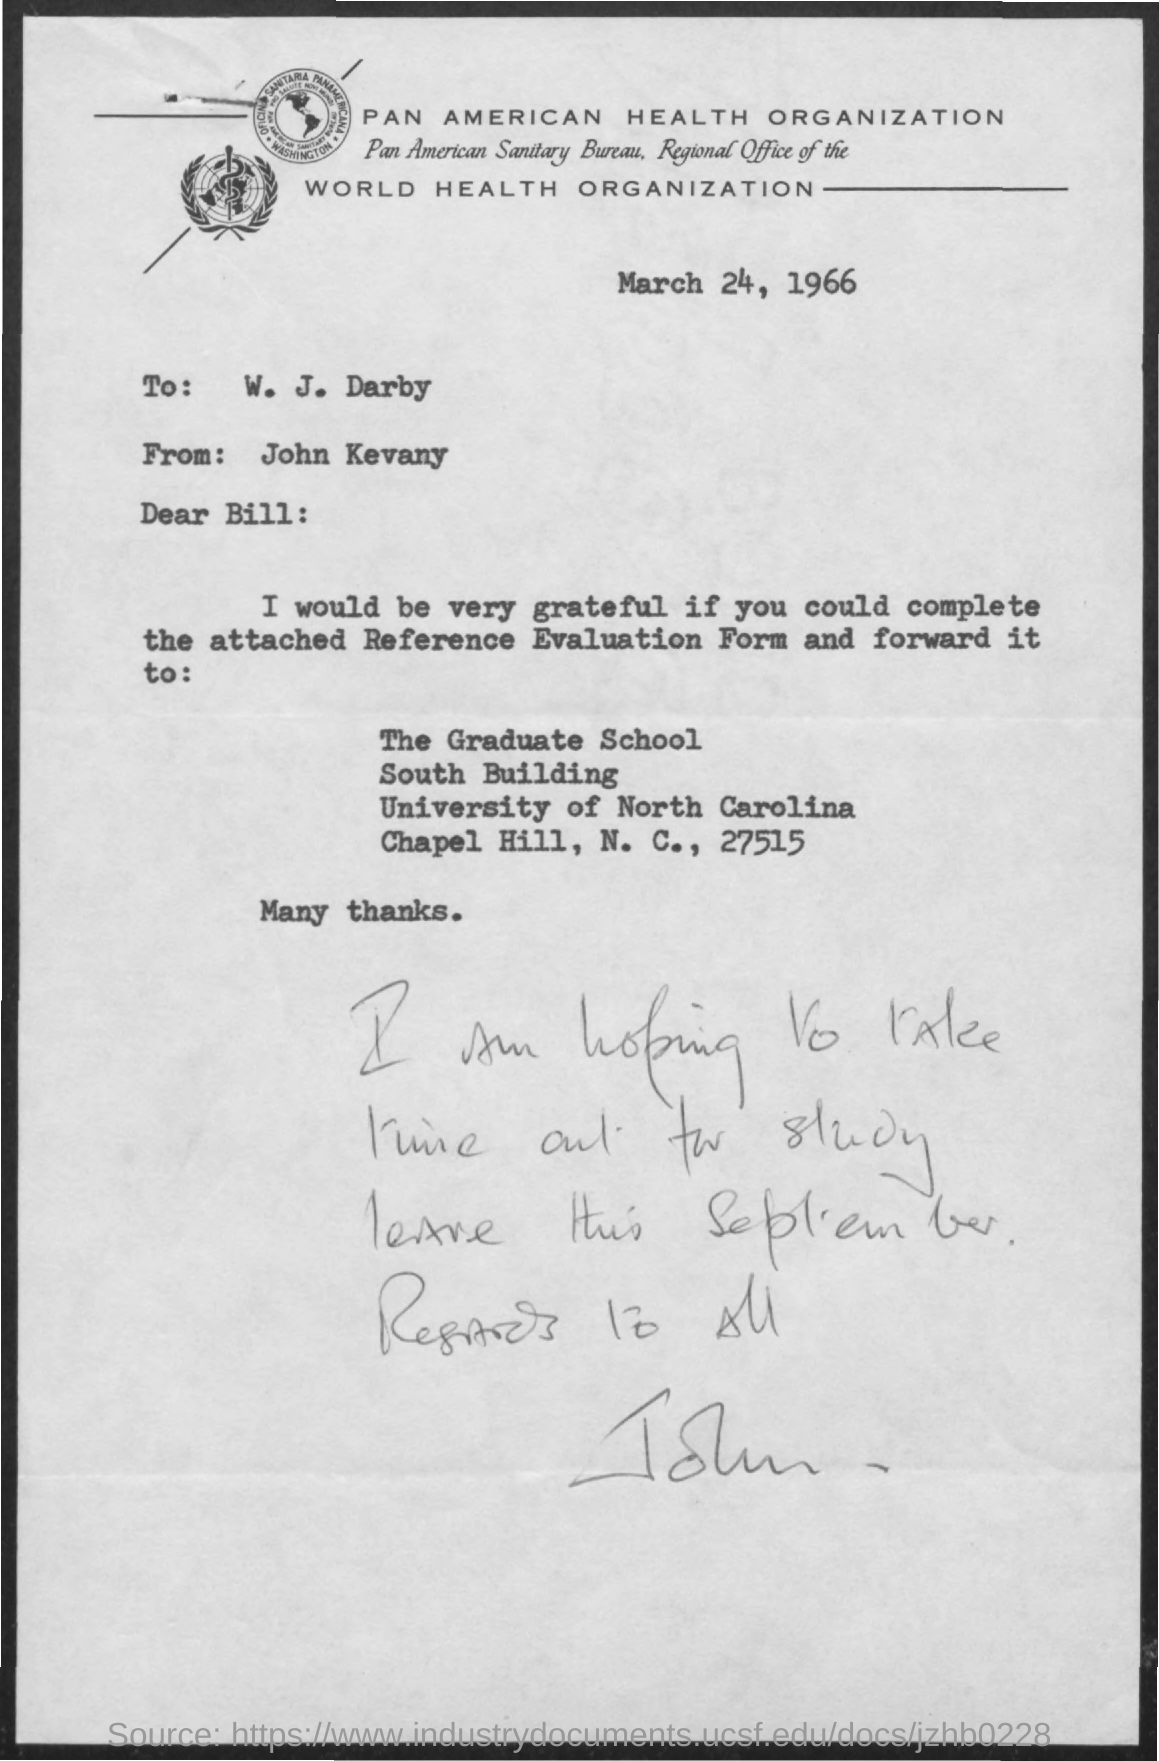Mention a couple of crucial points in this snapshot. The sender of this letter is John Kevany. The addressee of this letter is William J. Darby. The letter, dated March 24, 1966, states... The attached form is a Reference Evaluation Form. 